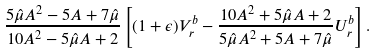Convert formula to latex. <formula><loc_0><loc_0><loc_500><loc_500>\frac { 5 \hat { \mu } A ^ { 2 } - 5 A + 7 \hat { \mu } } { 1 0 A ^ { 2 } - 5 \hat { \mu } A + 2 } \left [ ( 1 + \epsilon ) V _ { r } ^ { b } - \frac { 1 0 A ^ { 2 } + 5 \hat { \mu } A + 2 } { 5 \hat { \mu } A ^ { 2 } + 5 A + 7 \hat { \mu } } U _ { r } ^ { b } \right ] .</formula> 